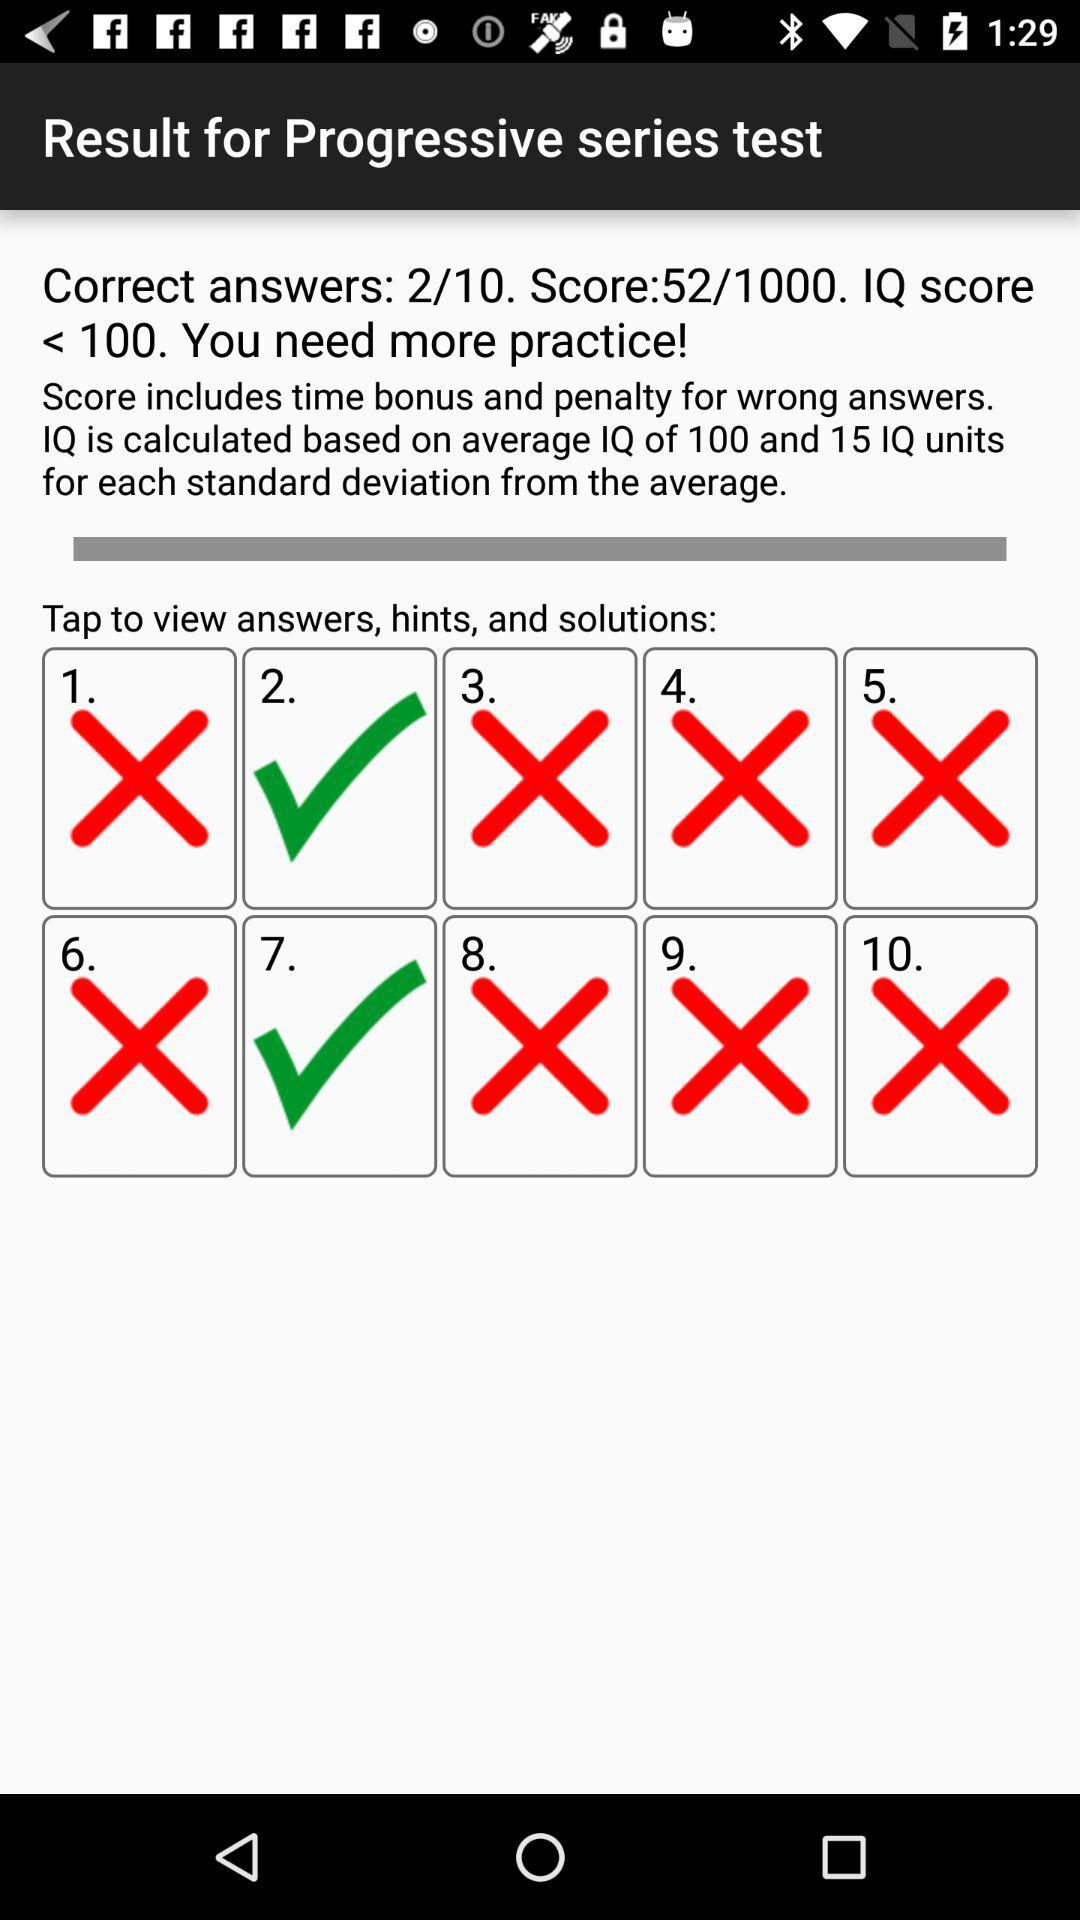What is the count for the correct answer? The count is 2. 